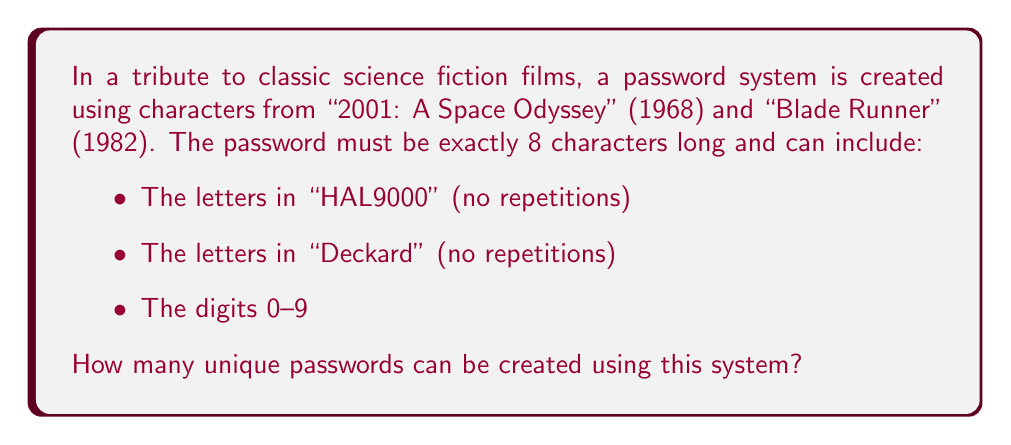Give your solution to this math problem. Let's approach this step-by-step:

1) First, let's count the unique characters available:
   - From "HAL9000": H, A, L (3 letters)
   - From "Deckard": D, E, C, K, R (5 letters)
   - Digits: 0, 1, 2, 3, 4, 5, 6, 7, 8, 9 (10 digits)

   Total unique characters: $3 + 5 + 10 = 18$

2) Now, we need to calculate the number of ways to arrange 8 characters from these 18 options.

3) This is a permutation problem. The order matters (as it's a password), and repetition is allowed (we can use any digit or letter multiple times).

4) The formula for permutations with repetition is:

   $$ n^r $$

   Where $n$ is the number of options for each position, and $r$ is the number of positions.

5) In this case:
   $n = 18$ (total unique characters)
   $r = 8$ (password length)

6) Therefore, the number of possible passwords is:

   $$ 18^8 = 110,075,314,176 $$

This large number showcases the importance of using varied characters in passwords, a concept that even the advanced computers in classic sci-fi films would appreciate.
Answer: $18^8 = 110,075,314,176$ 